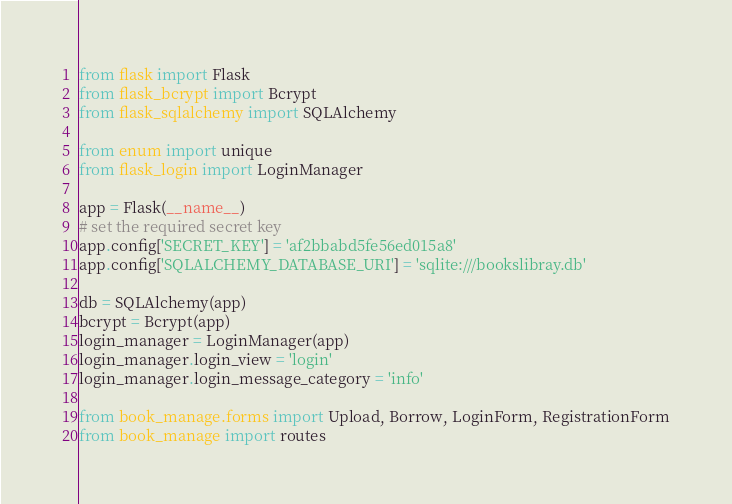Convert code to text. <code><loc_0><loc_0><loc_500><loc_500><_Python_>
from flask import Flask
from flask_bcrypt import Bcrypt
from flask_sqlalchemy import SQLAlchemy

from enum import unique
from flask_login import LoginManager

app = Flask(__name__)
# set the required secret key
app.config['SECRET_KEY'] = 'af2bbabd5fe56ed015a8'
app.config['SQLALCHEMY_DATABASE_URI'] = 'sqlite:///bookslibray.db'

db = SQLAlchemy(app)
bcrypt = Bcrypt(app)
login_manager = LoginManager(app)
login_manager.login_view = 'login'
login_manager.login_message_category = 'info'

from book_manage.forms import Upload, Borrow, LoginForm, RegistrationForm
from book_manage import routes
</code> 